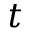Convert formula to latex. <formula><loc_0><loc_0><loc_500><loc_500>t</formula> 